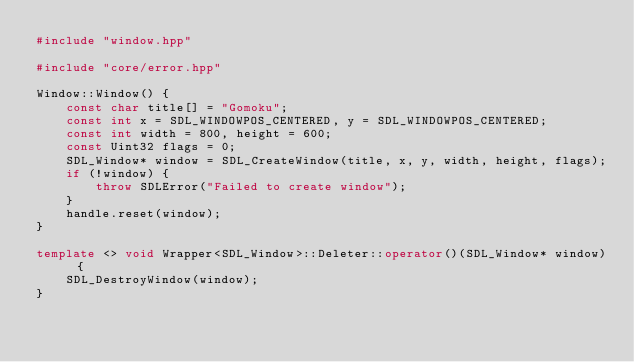<code> <loc_0><loc_0><loc_500><loc_500><_C++_>#include "window.hpp"

#include "core/error.hpp"

Window::Window() {
    const char title[] = "Gomoku";
    const int x = SDL_WINDOWPOS_CENTERED, y = SDL_WINDOWPOS_CENTERED;
    const int width = 800, height = 600;
    const Uint32 flags = 0;
    SDL_Window* window = SDL_CreateWindow(title, x, y, width, height, flags);
    if (!window) {
        throw SDLError("Failed to create window");
    }
    handle.reset(window);
}

template <> void Wrapper<SDL_Window>::Deleter::operator()(SDL_Window* window) {
    SDL_DestroyWindow(window);
}
</code> 